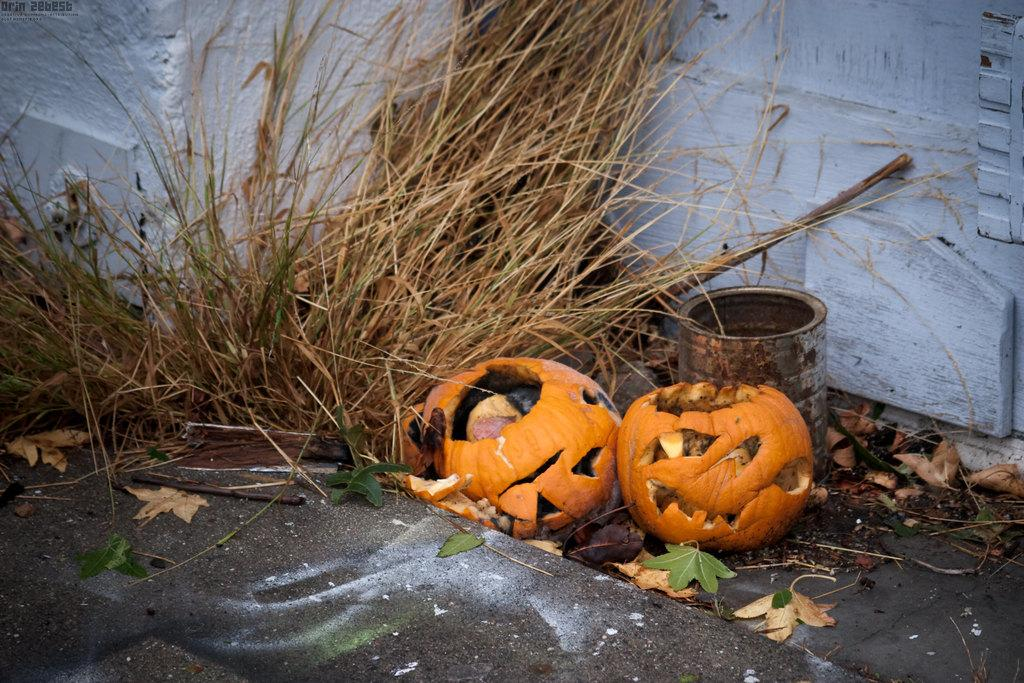How many pumpkins are in the image? There are two pumpkins in the image. What is located in the middle of the image? There is a tin in the middle of the image. What type of vegetation is at the bottom of the image? There are leaves at the bottom of the image. What can be seen in the background of the image? There is a wall and grass visible in the background of the image. What type of kettle is being exchanged between the pumpkins in the image? There is no kettle present in the image, nor is there any exchange happening between the pumpkins. 